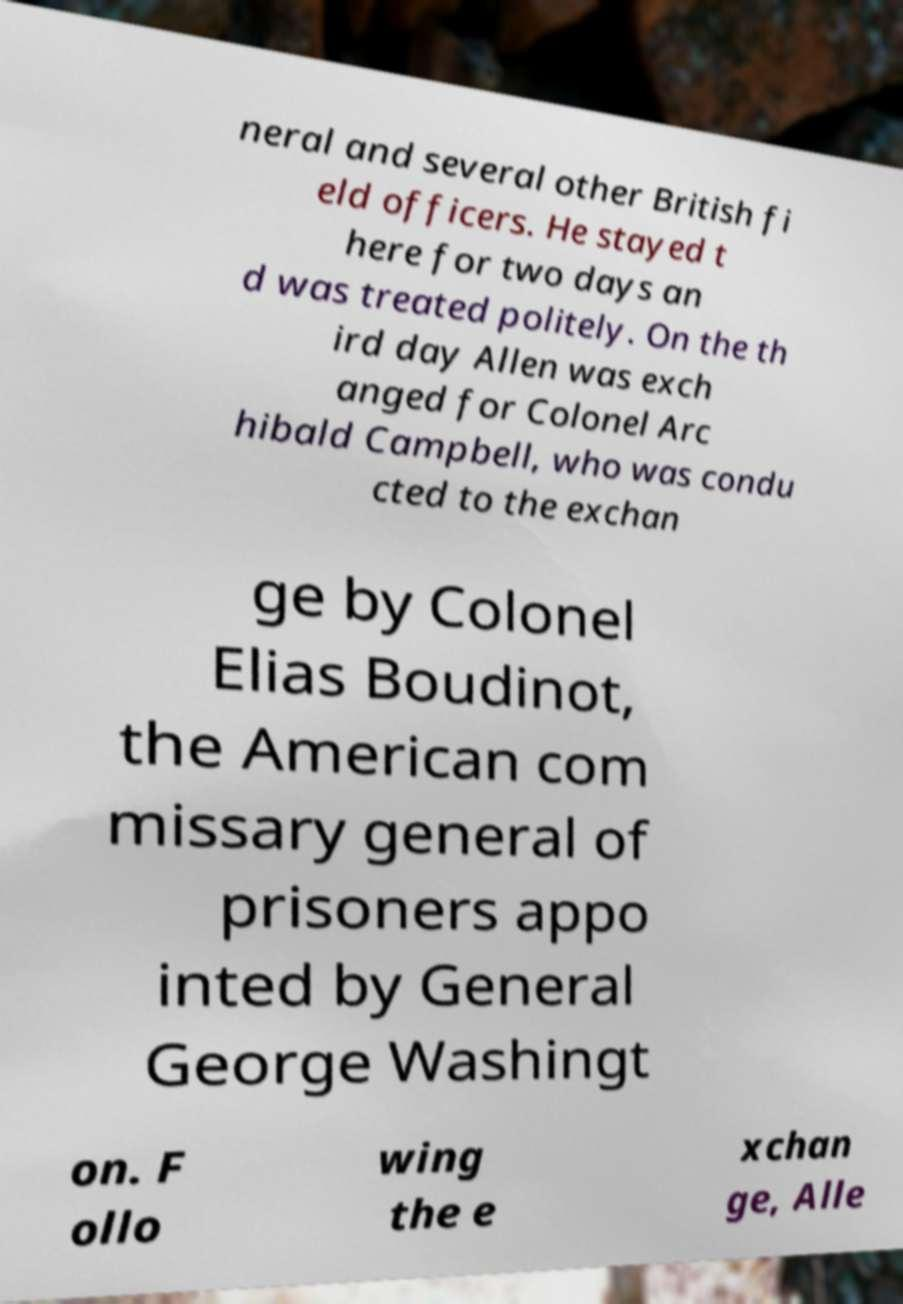Can you read and provide the text displayed in the image?This photo seems to have some interesting text. Can you extract and type it out for me? neral and several other British fi eld officers. He stayed t here for two days an d was treated politely. On the th ird day Allen was exch anged for Colonel Arc hibald Campbell, who was condu cted to the exchan ge by Colonel Elias Boudinot, the American com missary general of prisoners appo inted by General George Washingt on. F ollo wing the e xchan ge, Alle 